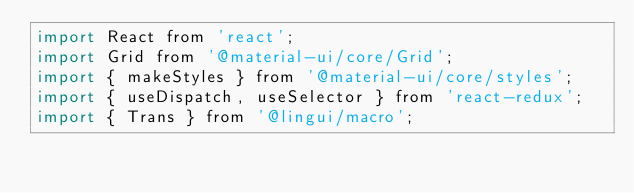<code> <loc_0><loc_0><loc_500><loc_500><_JavaScript_>import React from 'react';
import Grid from '@material-ui/core/Grid';
import { makeStyles } from '@material-ui/core/styles';
import { useDispatch, useSelector } from 'react-redux';
import { Trans } from '@lingui/macro';</code> 